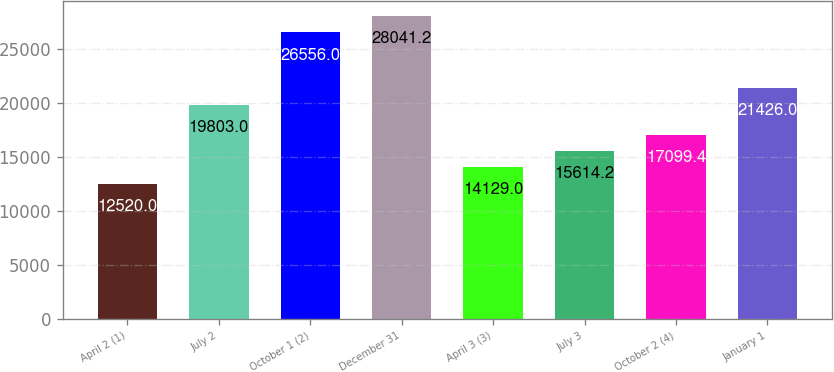Convert chart. <chart><loc_0><loc_0><loc_500><loc_500><bar_chart><fcel>April 2 (1)<fcel>July 2<fcel>October 1 (2)<fcel>December 31<fcel>April 3 (3)<fcel>July 3<fcel>October 2 (4)<fcel>January 1<nl><fcel>12520<fcel>19803<fcel>26556<fcel>28041.2<fcel>14129<fcel>15614.2<fcel>17099.4<fcel>21426<nl></chart> 